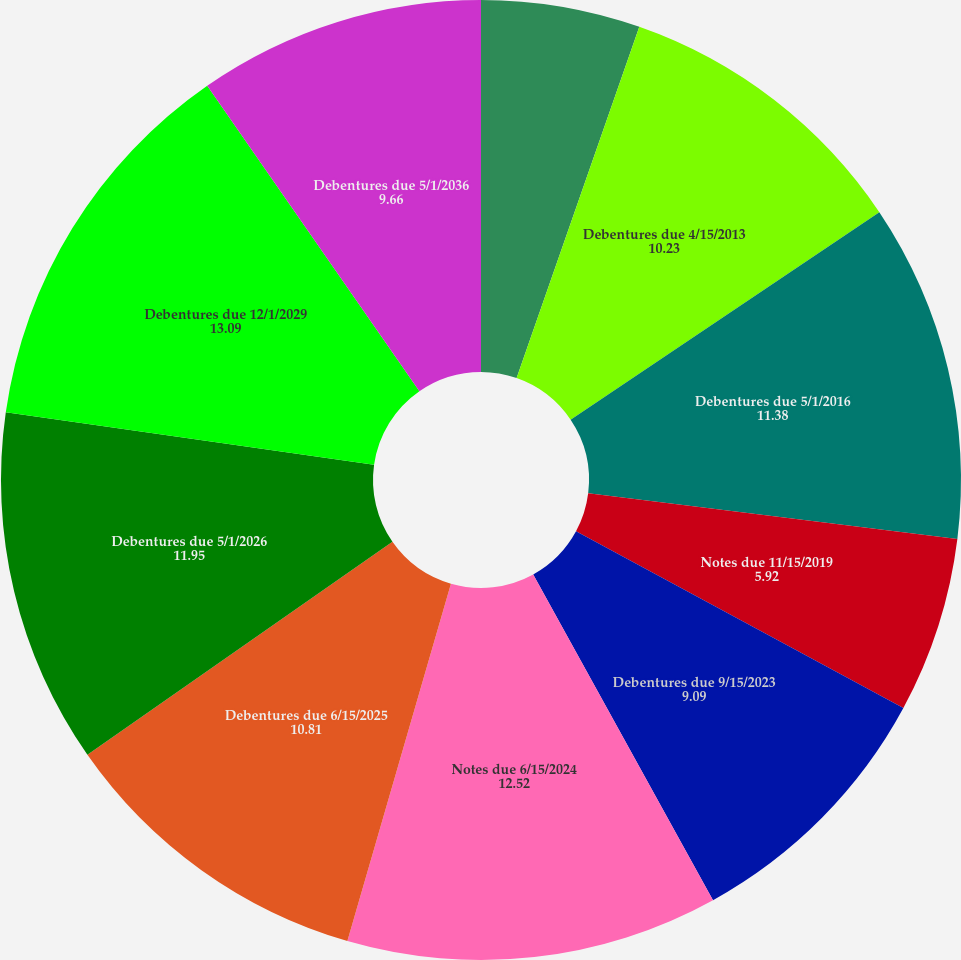<chart> <loc_0><loc_0><loc_500><loc_500><pie_chart><fcel>Notes due 3/14/2013<fcel>Debentures due 4/15/2013<fcel>Debentures due 5/1/2016<fcel>Notes due 11/15/2019<fcel>Debentures due 9/15/2023<fcel>Notes due 6/15/2024<fcel>Debentures due 6/15/2025<fcel>Debentures due 5/1/2026<fcel>Debentures due 12/1/2029<fcel>Debentures due 5/1/2036<nl><fcel>5.35%<fcel>10.23%<fcel>11.38%<fcel>5.92%<fcel>9.09%<fcel>12.52%<fcel>10.81%<fcel>11.95%<fcel>13.09%<fcel>9.66%<nl></chart> 